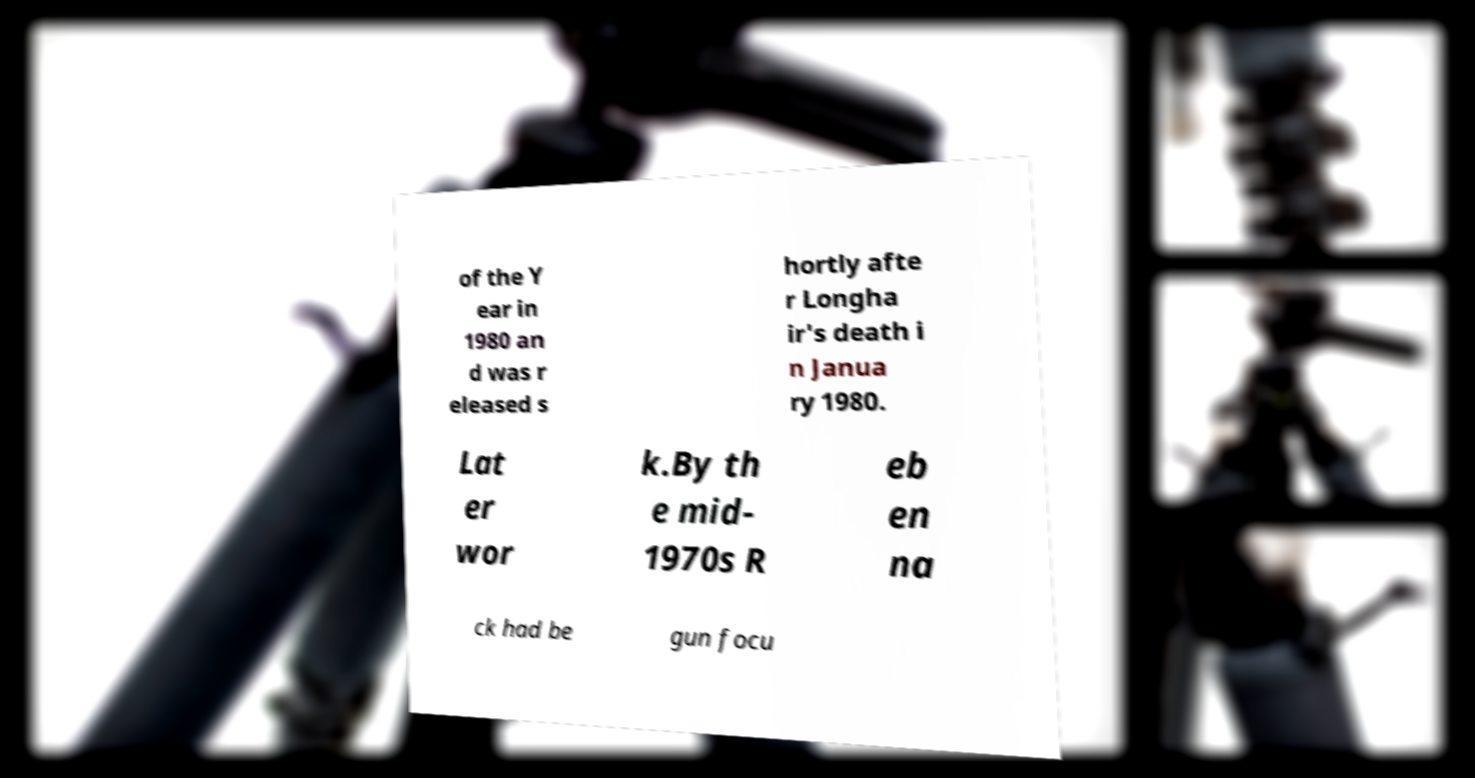Can you accurately transcribe the text from the provided image for me? of the Y ear in 1980 an d was r eleased s hortly afte r Longha ir's death i n Janua ry 1980. Lat er wor k.By th e mid- 1970s R eb en na ck had be gun focu 